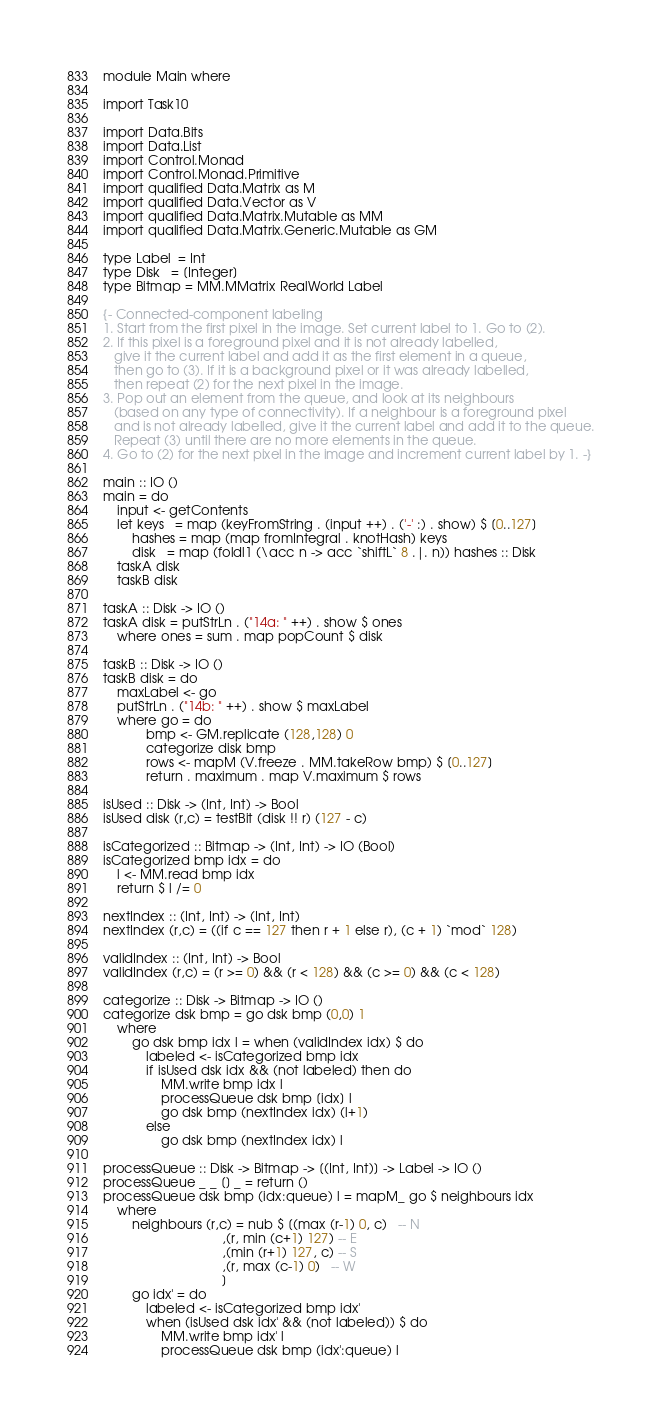<code> <loc_0><loc_0><loc_500><loc_500><_Haskell_>module Main where

import Task10

import Data.Bits
import Data.List
import Control.Monad
import Control.Monad.Primitive
import qualified Data.Matrix as M
import qualified Data.Vector as V
import qualified Data.Matrix.Mutable as MM
import qualified Data.Matrix.Generic.Mutable as GM

type Label  = Int
type Disk   = [Integer]
type Bitmap = MM.MMatrix RealWorld Label

{- Connected-component labeling
1. Start from the first pixel in the image. Set current label to 1. Go to (2).
2. If this pixel is a foreground pixel and it is not already labelled,
   give it the current label and add it as the first element in a queue,
   then go to (3). If it is a background pixel or it was already labelled,
   then repeat (2) for the next pixel in the image.
3. Pop out an element from the queue, and look at its neighbours
   (based on any type of connectivity). If a neighbour is a foreground pixel
   and is not already labelled, give it the current label and add it to the queue.
   Repeat (3) until there are no more elements in the queue.
4. Go to (2) for the next pixel in the image and increment current label by 1. -}

main :: IO ()
main = do
    input <- getContents
    let keys   = map (keyFromString . (input ++) . ('-' :) . show) $ [0..127]
        hashes = map (map fromIntegral . knotHash) keys
        disk   = map (foldl1 (\acc n -> acc `shiftL` 8 .|. n)) hashes :: Disk
    taskA disk
    taskB disk

taskA :: Disk -> IO ()
taskA disk = putStrLn . ("14a: " ++) . show $ ones
    where ones = sum . map popCount $ disk

taskB :: Disk -> IO ()
taskB disk = do
    maxLabel <- go
    putStrLn . ("14b: " ++) . show $ maxLabel
    where go = do
            bmp <- GM.replicate (128,128) 0
            categorize disk bmp
            rows <- mapM (V.freeze . MM.takeRow bmp) $ [0..127]
            return . maximum . map V.maximum $ rows

isUsed :: Disk -> (Int, Int) -> Bool
isUsed disk (r,c) = testBit (disk !! r) (127 - c)

isCategorized :: Bitmap -> (Int, Int) -> IO (Bool)
isCategorized bmp idx = do
    l <- MM.read bmp idx
    return $ l /= 0

nextIndex :: (Int, Int) -> (Int, Int)
nextIndex (r,c) = ((if c == 127 then r + 1 else r), (c + 1) `mod` 128)

validIndex :: (Int, Int) -> Bool
validIndex (r,c) = (r >= 0) && (r < 128) && (c >= 0) && (c < 128)

categorize :: Disk -> Bitmap -> IO ()
categorize dsk bmp = go dsk bmp (0,0) 1
    where
        go dsk bmp idx l = when (validIndex idx) $ do
            labeled <- isCategorized bmp idx
            if isUsed dsk idx && (not labeled) then do
                MM.write bmp idx l
                processQueue dsk bmp [idx] l
                go dsk bmp (nextIndex idx) (l+1)
            else
                go dsk bmp (nextIndex idx) l

processQueue :: Disk -> Bitmap -> [(Int, Int)] -> Label -> IO ()
processQueue _ _ [] _ = return ()
processQueue dsk bmp (idx:queue) l = mapM_ go $ neighbours idx
    where
        neighbours (r,c) = nub $ [(max (r-1) 0, c)   -- N
                                 ,(r, min (c+1) 127) -- E
                                 ,(min (r+1) 127, c) -- S
                                 ,(r, max (c-1) 0)   -- W
                                 ]
        go idx' = do
            labeled <- isCategorized bmp idx'
            when (isUsed dsk idx' && (not labeled)) $ do
                MM.write bmp idx' l
                processQueue dsk bmp (idx':queue) l
</code> 